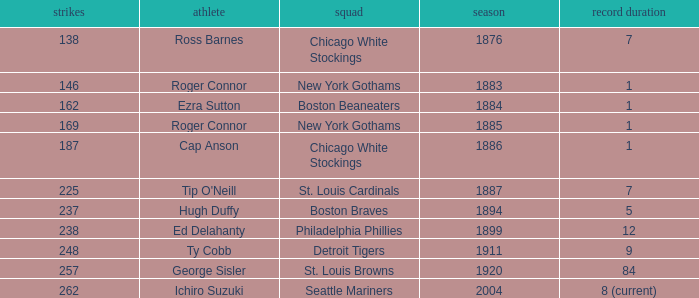Which player had 238 hits in the years post-1885? Ed Delahanty. 